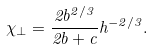Convert formula to latex. <formula><loc_0><loc_0><loc_500><loc_500>\chi _ { \perp } = \frac { 2 b ^ { 2 / 3 } } { 2 b + c } h ^ { - 2 / 3 } .</formula> 